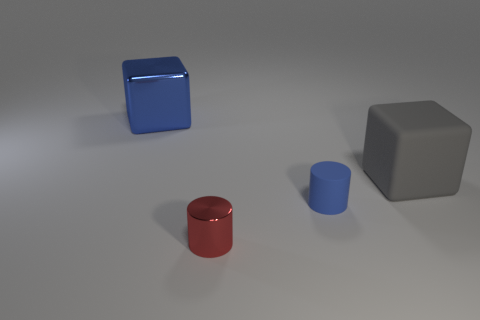Add 4 big blue things. How many objects exist? 8 Subtract all tiny metal things. Subtract all small things. How many objects are left? 1 Add 2 blue cubes. How many blue cubes are left? 3 Add 2 blue cubes. How many blue cubes exist? 3 Subtract 0 yellow balls. How many objects are left? 4 